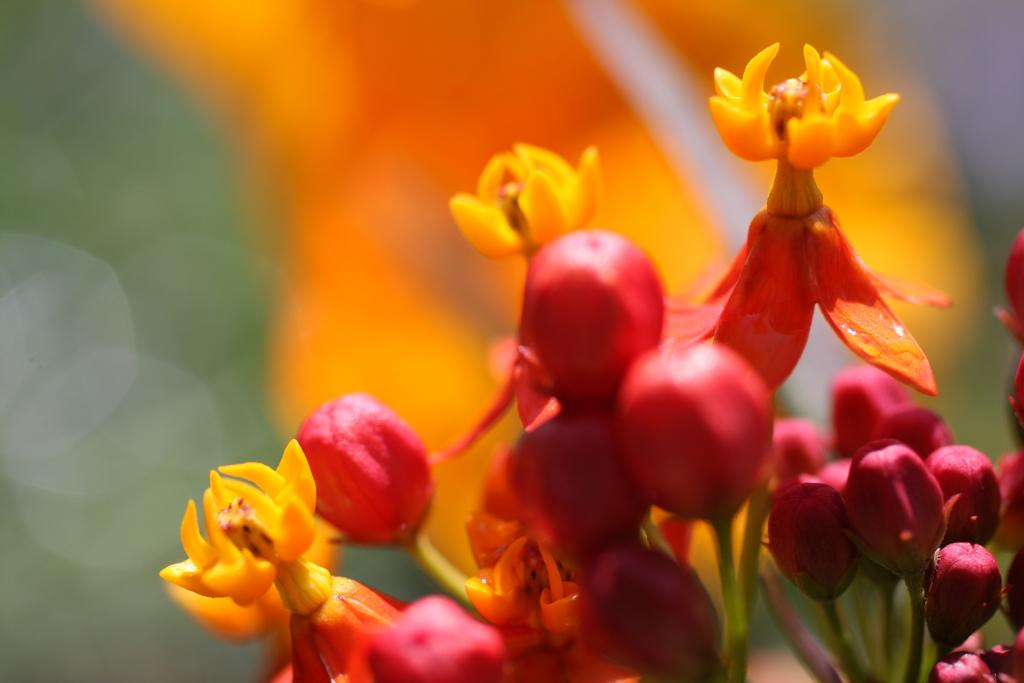What can be seen on the right side of the image? There is a group of flowers on the right side of the image. What else is visible in the image besides the group of flowers? In the background of the image, there are flowers and plants visible. What type of quill can be seen in the image? There is no quill present in the image. Can you describe the duck in the image? There is no duck present in the image. 